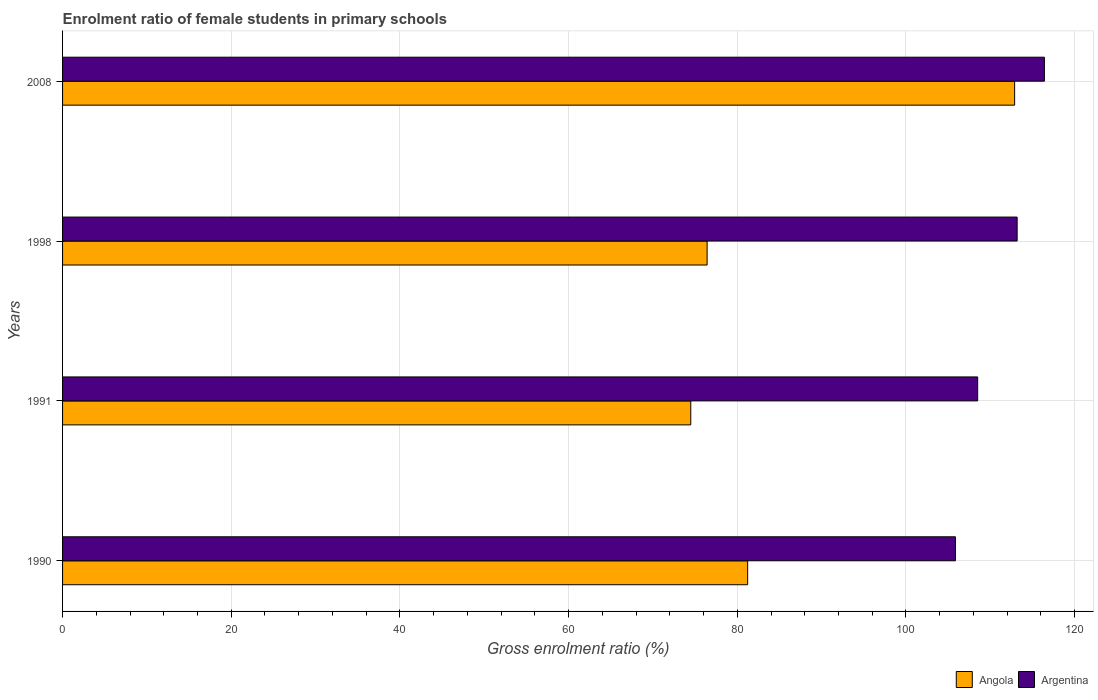How many different coloured bars are there?
Give a very brief answer. 2. How many bars are there on the 3rd tick from the bottom?
Keep it short and to the point. 2. In how many cases, is the number of bars for a given year not equal to the number of legend labels?
Your answer should be very brief. 0. What is the enrolment ratio of female students in primary schools in Angola in 2008?
Offer a terse response. 112.89. Across all years, what is the maximum enrolment ratio of female students in primary schools in Angola?
Your answer should be very brief. 112.89. Across all years, what is the minimum enrolment ratio of female students in primary schools in Angola?
Provide a short and direct response. 74.49. In which year was the enrolment ratio of female students in primary schools in Argentina minimum?
Provide a short and direct response. 1990. What is the total enrolment ratio of female students in primary schools in Angola in the graph?
Keep it short and to the point. 345.03. What is the difference between the enrolment ratio of female students in primary schools in Angola in 1990 and that in 2008?
Provide a succinct answer. -31.65. What is the difference between the enrolment ratio of female students in primary schools in Argentina in 1990 and the enrolment ratio of female students in primary schools in Angola in 1998?
Make the answer very short. 29.45. What is the average enrolment ratio of female students in primary schools in Argentina per year?
Offer a very short reply. 110.99. In the year 1990, what is the difference between the enrolment ratio of female students in primary schools in Argentina and enrolment ratio of female students in primary schools in Angola?
Make the answer very short. 24.64. In how many years, is the enrolment ratio of female students in primary schools in Angola greater than 104 %?
Your response must be concise. 1. What is the ratio of the enrolment ratio of female students in primary schools in Argentina in 1990 to that in 1991?
Ensure brevity in your answer.  0.98. Is the difference between the enrolment ratio of female students in primary schools in Argentina in 1990 and 1991 greater than the difference between the enrolment ratio of female students in primary schools in Angola in 1990 and 1991?
Keep it short and to the point. No. What is the difference between the highest and the second highest enrolment ratio of female students in primary schools in Argentina?
Provide a succinct answer. 3.23. What is the difference between the highest and the lowest enrolment ratio of female students in primary schools in Argentina?
Offer a terse response. 10.54. In how many years, is the enrolment ratio of female students in primary schools in Argentina greater than the average enrolment ratio of female students in primary schools in Argentina taken over all years?
Offer a terse response. 2. What does the 1st bar from the bottom in 1998 represents?
Provide a short and direct response. Angola. How many years are there in the graph?
Your answer should be very brief. 4. What is the difference between two consecutive major ticks on the X-axis?
Make the answer very short. 20. Are the values on the major ticks of X-axis written in scientific E-notation?
Offer a terse response. No. Does the graph contain any zero values?
Ensure brevity in your answer.  No. Does the graph contain grids?
Give a very brief answer. Yes. Where does the legend appear in the graph?
Keep it short and to the point. Bottom right. How are the legend labels stacked?
Offer a terse response. Horizontal. What is the title of the graph?
Provide a short and direct response. Enrolment ratio of female students in primary schools. Does "Burkina Faso" appear as one of the legend labels in the graph?
Your response must be concise. No. What is the label or title of the X-axis?
Give a very brief answer. Gross enrolment ratio (%). What is the label or title of the Y-axis?
Give a very brief answer. Years. What is the Gross enrolment ratio (%) in Angola in 1990?
Make the answer very short. 81.23. What is the Gross enrolment ratio (%) in Argentina in 1990?
Your answer should be compact. 105.87. What is the Gross enrolment ratio (%) in Angola in 1991?
Ensure brevity in your answer.  74.49. What is the Gross enrolment ratio (%) of Argentina in 1991?
Your answer should be compact. 108.5. What is the Gross enrolment ratio (%) of Angola in 1998?
Provide a succinct answer. 76.42. What is the Gross enrolment ratio (%) in Argentina in 1998?
Your answer should be very brief. 113.18. What is the Gross enrolment ratio (%) of Angola in 2008?
Provide a short and direct response. 112.89. What is the Gross enrolment ratio (%) of Argentina in 2008?
Provide a short and direct response. 116.42. Across all years, what is the maximum Gross enrolment ratio (%) of Angola?
Your answer should be very brief. 112.89. Across all years, what is the maximum Gross enrolment ratio (%) in Argentina?
Provide a short and direct response. 116.42. Across all years, what is the minimum Gross enrolment ratio (%) of Angola?
Give a very brief answer. 74.49. Across all years, what is the minimum Gross enrolment ratio (%) in Argentina?
Your answer should be very brief. 105.87. What is the total Gross enrolment ratio (%) of Angola in the graph?
Provide a succinct answer. 345.03. What is the total Gross enrolment ratio (%) in Argentina in the graph?
Give a very brief answer. 443.98. What is the difference between the Gross enrolment ratio (%) of Angola in 1990 and that in 1991?
Make the answer very short. 6.74. What is the difference between the Gross enrolment ratio (%) of Argentina in 1990 and that in 1991?
Ensure brevity in your answer.  -2.63. What is the difference between the Gross enrolment ratio (%) in Angola in 1990 and that in 1998?
Your answer should be compact. 4.81. What is the difference between the Gross enrolment ratio (%) of Argentina in 1990 and that in 1998?
Ensure brevity in your answer.  -7.31. What is the difference between the Gross enrolment ratio (%) of Angola in 1990 and that in 2008?
Provide a short and direct response. -31.65. What is the difference between the Gross enrolment ratio (%) of Argentina in 1990 and that in 2008?
Provide a succinct answer. -10.54. What is the difference between the Gross enrolment ratio (%) of Angola in 1991 and that in 1998?
Keep it short and to the point. -1.94. What is the difference between the Gross enrolment ratio (%) of Argentina in 1991 and that in 1998?
Your answer should be very brief. -4.68. What is the difference between the Gross enrolment ratio (%) of Angola in 1991 and that in 2008?
Make the answer very short. -38.4. What is the difference between the Gross enrolment ratio (%) in Argentina in 1991 and that in 2008?
Your answer should be compact. -7.91. What is the difference between the Gross enrolment ratio (%) of Angola in 1998 and that in 2008?
Your response must be concise. -36.46. What is the difference between the Gross enrolment ratio (%) in Argentina in 1998 and that in 2008?
Offer a very short reply. -3.23. What is the difference between the Gross enrolment ratio (%) of Angola in 1990 and the Gross enrolment ratio (%) of Argentina in 1991?
Offer a terse response. -27.27. What is the difference between the Gross enrolment ratio (%) in Angola in 1990 and the Gross enrolment ratio (%) in Argentina in 1998?
Keep it short and to the point. -31.95. What is the difference between the Gross enrolment ratio (%) in Angola in 1990 and the Gross enrolment ratio (%) in Argentina in 2008?
Provide a succinct answer. -35.18. What is the difference between the Gross enrolment ratio (%) of Angola in 1991 and the Gross enrolment ratio (%) of Argentina in 1998?
Ensure brevity in your answer.  -38.7. What is the difference between the Gross enrolment ratio (%) of Angola in 1991 and the Gross enrolment ratio (%) of Argentina in 2008?
Provide a succinct answer. -41.93. What is the difference between the Gross enrolment ratio (%) of Angola in 1998 and the Gross enrolment ratio (%) of Argentina in 2008?
Provide a short and direct response. -39.99. What is the average Gross enrolment ratio (%) of Angola per year?
Offer a terse response. 86.26. What is the average Gross enrolment ratio (%) of Argentina per year?
Offer a very short reply. 110.99. In the year 1990, what is the difference between the Gross enrolment ratio (%) of Angola and Gross enrolment ratio (%) of Argentina?
Provide a short and direct response. -24.64. In the year 1991, what is the difference between the Gross enrolment ratio (%) of Angola and Gross enrolment ratio (%) of Argentina?
Make the answer very short. -34.02. In the year 1998, what is the difference between the Gross enrolment ratio (%) of Angola and Gross enrolment ratio (%) of Argentina?
Give a very brief answer. -36.76. In the year 2008, what is the difference between the Gross enrolment ratio (%) in Angola and Gross enrolment ratio (%) in Argentina?
Give a very brief answer. -3.53. What is the ratio of the Gross enrolment ratio (%) of Angola in 1990 to that in 1991?
Offer a very short reply. 1.09. What is the ratio of the Gross enrolment ratio (%) in Argentina in 1990 to that in 1991?
Provide a succinct answer. 0.98. What is the ratio of the Gross enrolment ratio (%) of Angola in 1990 to that in 1998?
Offer a very short reply. 1.06. What is the ratio of the Gross enrolment ratio (%) of Argentina in 1990 to that in 1998?
Your answer should be very brief. 0.94. What is the ratio of the Gross enrolment ratio (%) of Angola in 1990 to that in 2008?
Offer a very short reply. 0.72. What is the ratio of the Gross enrolment ratio (%) in Argentina in 1990 to that in 2008?
Offer a very short reply. 0.91. What is the ratio of the Gross enrolment ratio (%) of Angola in 1991 to that in 1998?
Give a very brief answer. 0.97. What is the ratio of the Gross enrolment ratio (%) in Argentina in 1991 to that in 1998?
Make the answer very short. 0.96. What is the ratio of the Gross enrolment ratio (%) in Angola in 1991 to that in 2008?
Your response must be concise. 0.66. What is the ratio of the Gross enrolment ratio (%) of Argentina in 1991 to that in 2008?
Keep it short and to the point. 0.93. What is the ratio of the Gross enrolment ratio (%) in Angola in 1998 to that in 2008?
Offer a very short reply. 0.68. What is the ratio of the Gross enrolment ratio (%) of Argentina in 1998 to that in 2008?
Your answer should be very brief. 0.97. What is the difference between the highest and the second highest Gross enrolment ratio (%) in Angola?
Keep it short and to the point. 31.65. What is the difference between the highest and the second highest Gross enrolment ratio (%) of Argentina?
Ensure brevity in your answer.  3.23. What is the difference between the highest and the lowest Gross enrolment ratio (%) in Angola?
Provide a succinct answer. 38.4. What is the difference between the highest and the lowest Gross enrolment ratio (%) of Argentina?
Offer a terse response. 10.54. 